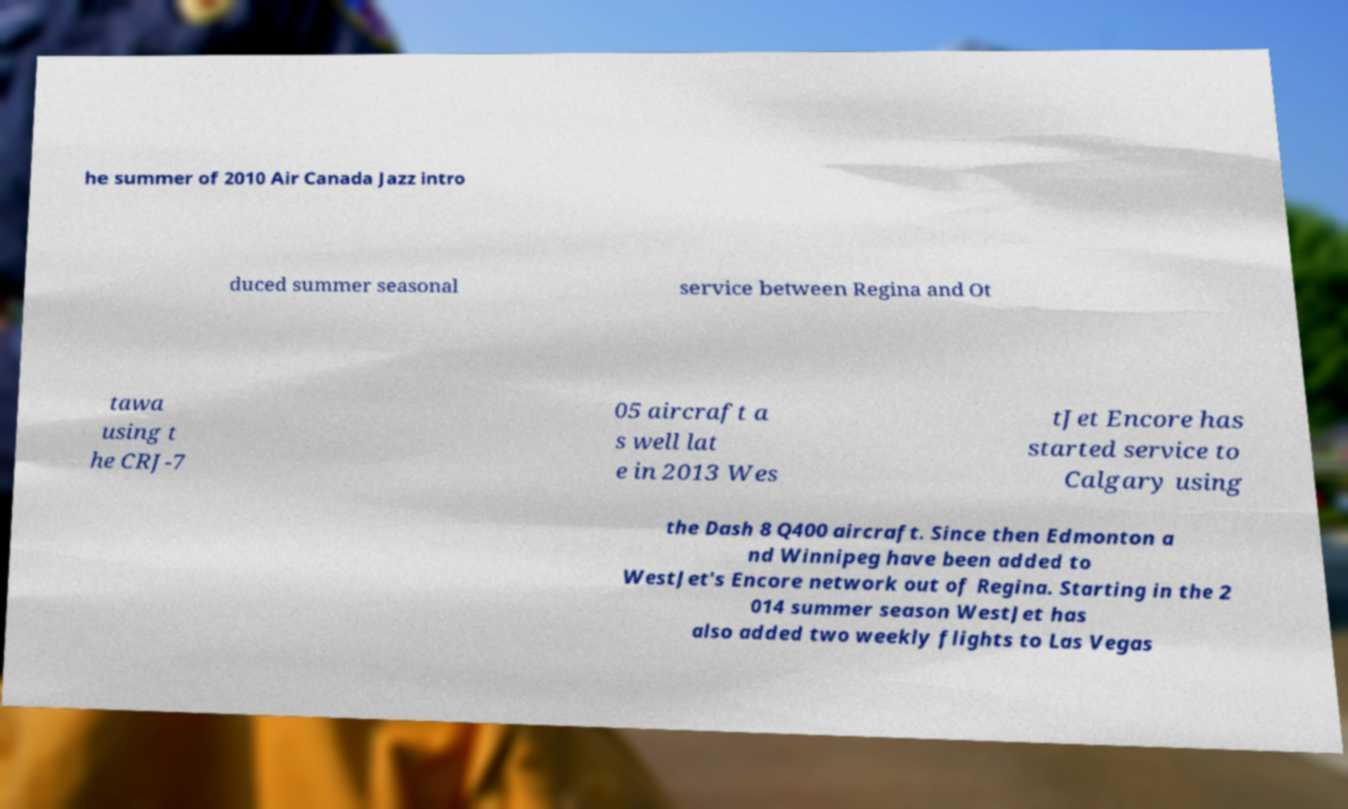Please identify and transcribe the text found in this image. he summer of 2010 Air Canada Jazz intro duced summer seasonal service between Regina and Ot tawa using t he CRJ-7 05 aircraft a s well lat e in 2013 Wes tJet Encore has started service to Calgary using the Dash 8 Q400 aircraft. Since then Edmonton a nd Winnipeg have been added to WestJet's Encore network out of Regina. Starting in the 2 014 summer season WestJet has also added two weekly flights to Las Vegas 